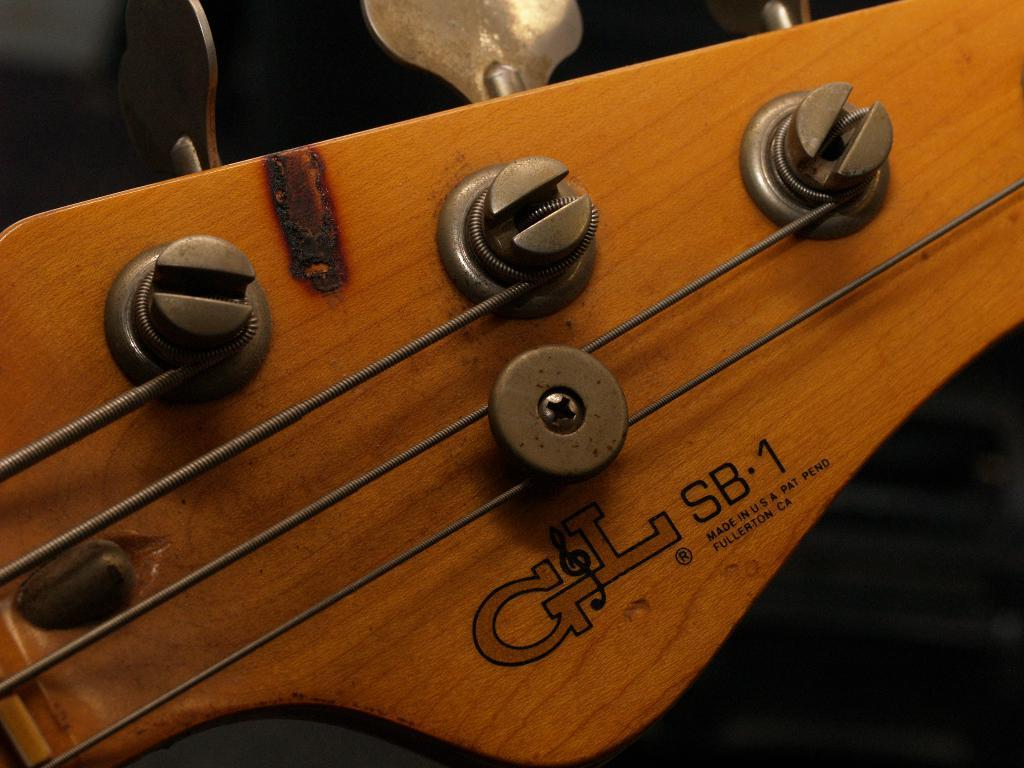What musical instrument is featured in the image? There is a guitar in the image. What is the focus of the image? The image provides a closer view of the guitar. Are there any specific parts of the guitar that are visible in the image? Yes, nuts are visible in the image. What type of liquid is being poured on the guitar in the image? There is no liquid being poured on the guitar in the image. What advice is given to the guitarist in the image? There is no advice being given in the image, as it is a static photograph of a guitar. 